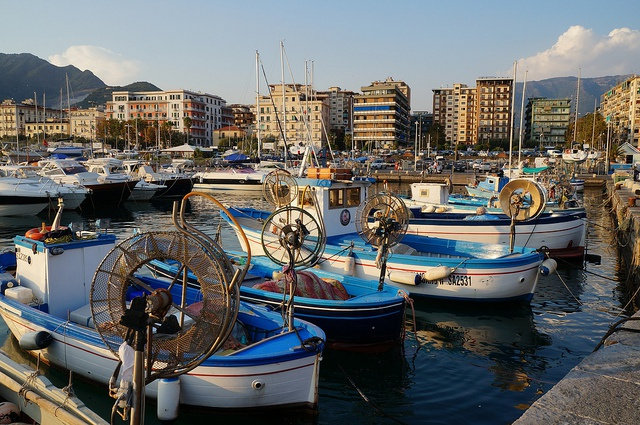Describe the objects in this image and their specific colors. I can see boat in lightblue, gray, black, and darkgray tones, boat in lightblue, black, gray, and darkgray tones, boat in lightblue, black, teal, gray, and maroon tones, boat in lightblue, black, gray, tan, and darkgray tones, and boat in lightblue, black, darkgray, gray, and purple tones in this image. 